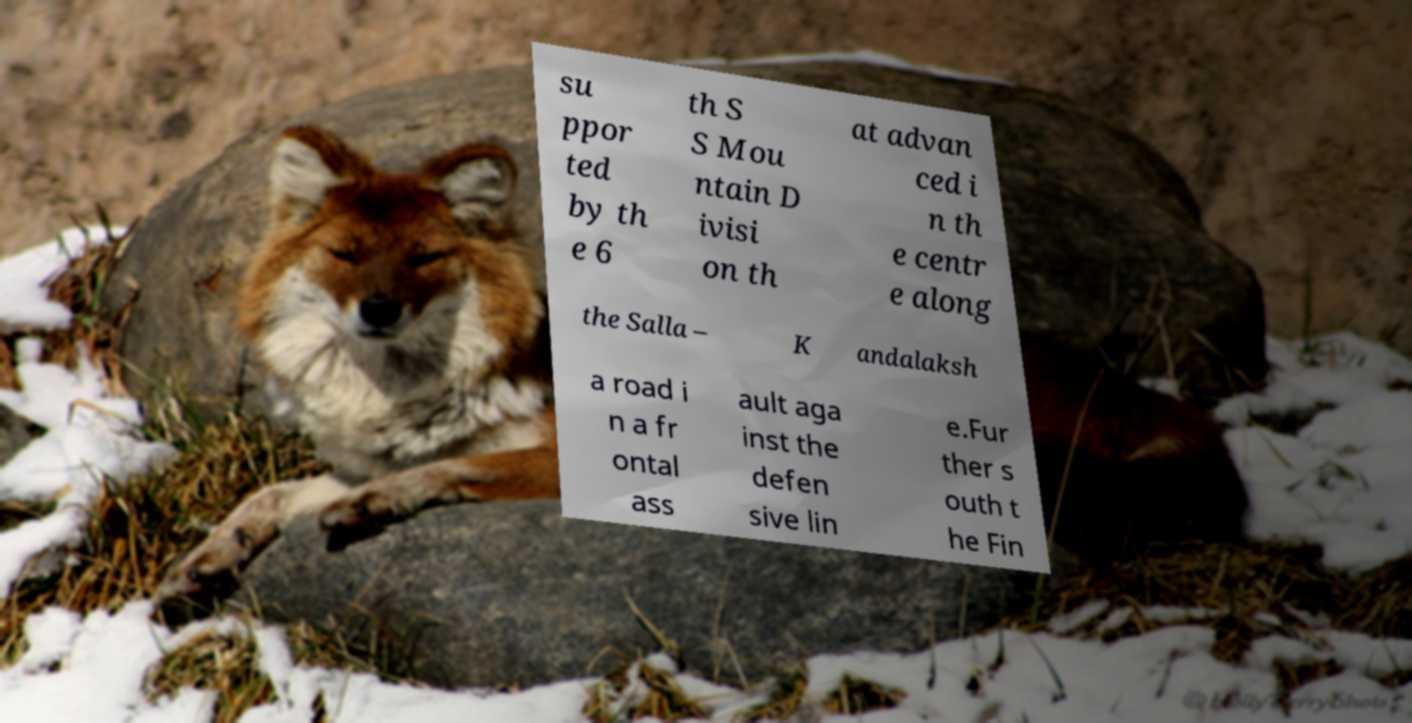For documentation purposes, I need the text within this image transcribed. Could you provide that? su ppor ted by th e 6 th S S Mou ntain D ivisi on th at advan ced i n th e centr e along the Salla – K andalaksh a road i n a fr ontal ass ault aga inst the defen sive lin e.Fur ther s outh t he Fin 